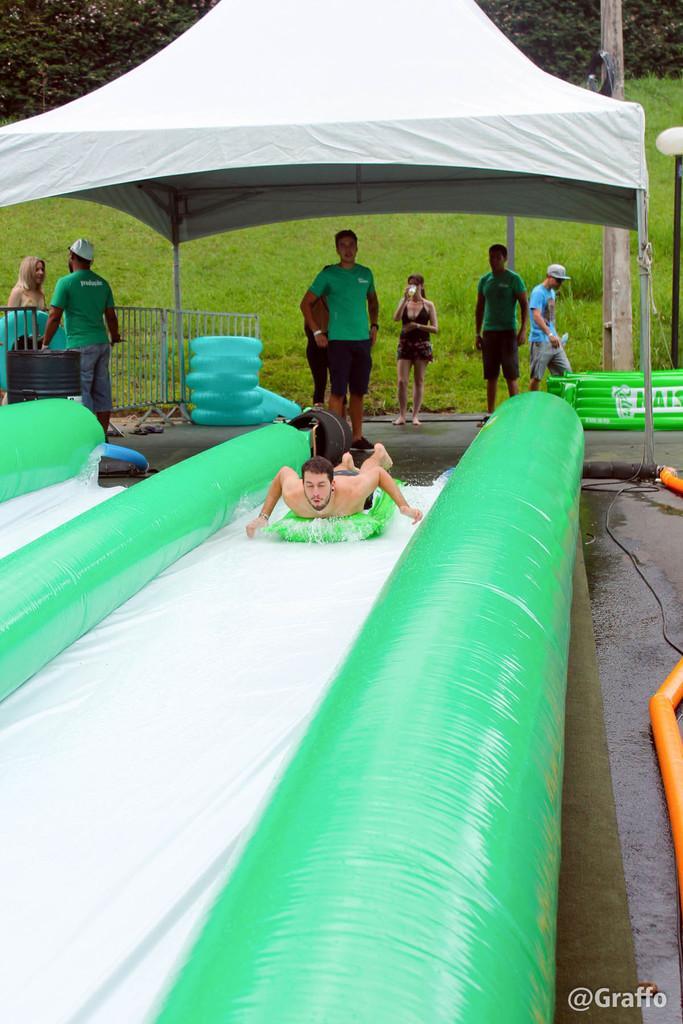In one or two sentences, can you explain what this image depicts? In this image, we can see a person on the water slide. On the right side of the image, we can see wires and orange color objects. Background we can see people, fence, barrel, tubes, grass, tent, light pole and trees. 